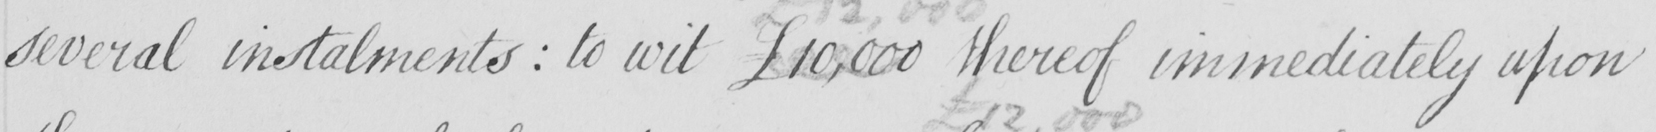Can you read and transcribe this handwriting? several instalments  :  to wit £10,000 thereof immediately upon 